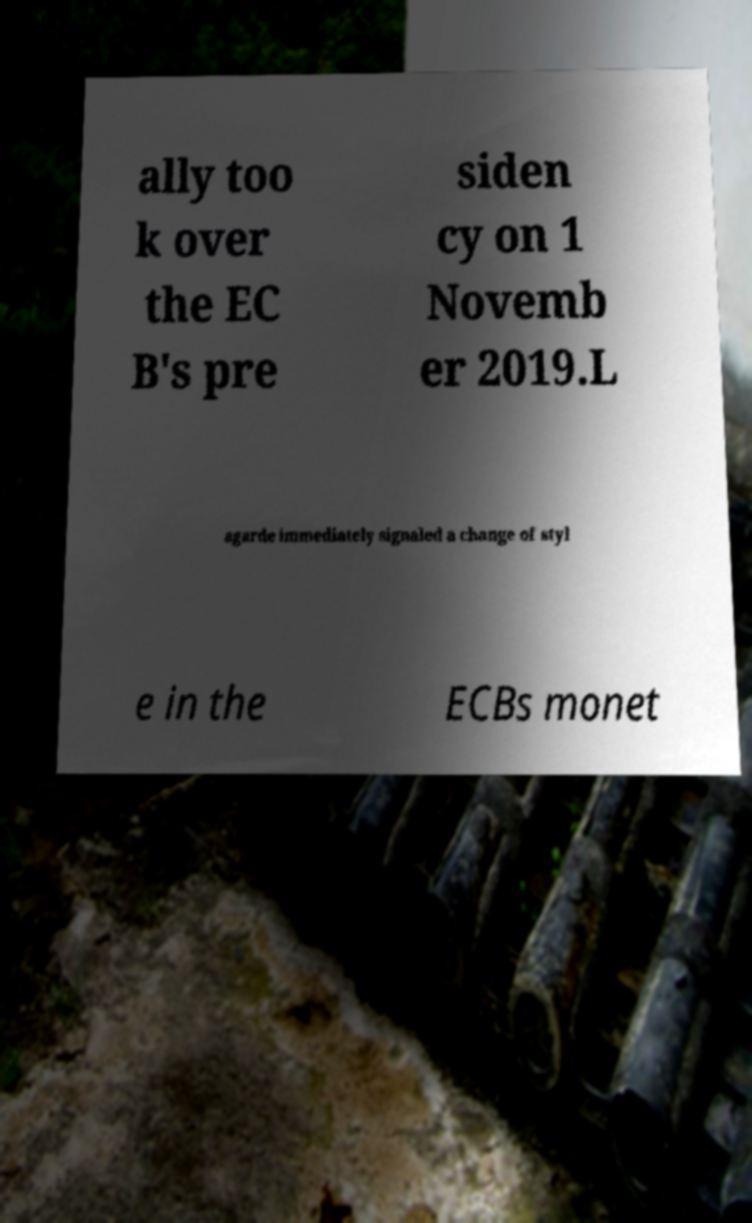I need the written content from this picture converted into text. Can you do that? ally too k over the EC B's pre siden cy on 1 Novemb er 2019.L agarde immediately signaled a change of styl e in the ECBs monet 